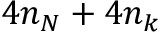Convert formula to latex. <formula><loc_0><loc_0><loc_500><loc_500>4 n _ { N } + 4 n _ { k }</formula> 